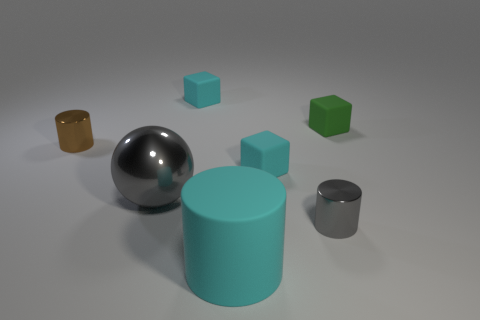What is the material of the tiny cylinder behind the gray shiny thing left of the tiny gray cylinder?
Provide a short and direct response. Metal. Are there any tiny blocks that have the same color as the large rubber cylinder?
Provide a short and direct response. Yes. There is a sphere that is in front of the brown metallic cylinder; what is its material?
Make the answer very short. Metal. There is a shiny object that is in front of the brown metallic thing and behind the gray cylinder; what size is it?
Give a very brief answer. Large. What is the color of the other small object that is the same shape as the brown metallic object?
Your answer should be very brief. Gray. Are there more small cubes in front of the brown object than big things behind the shiny sphere?
Offer a very short reply. Yes. How many other objects are the same shape as the brown object?
Provide a short and direct response. 2. Is there a metallic cylinder to the left of the tiny metal cylinder that is in front of the gray metal sphere?
Offer a very short reply. Yes. How many gray metallic spheres are there?
Offer a terse response. 1. There is a big metal thing; does it have the same color as the thing that is in front of the gray metal cylinder?
Your response must be concise. No. 